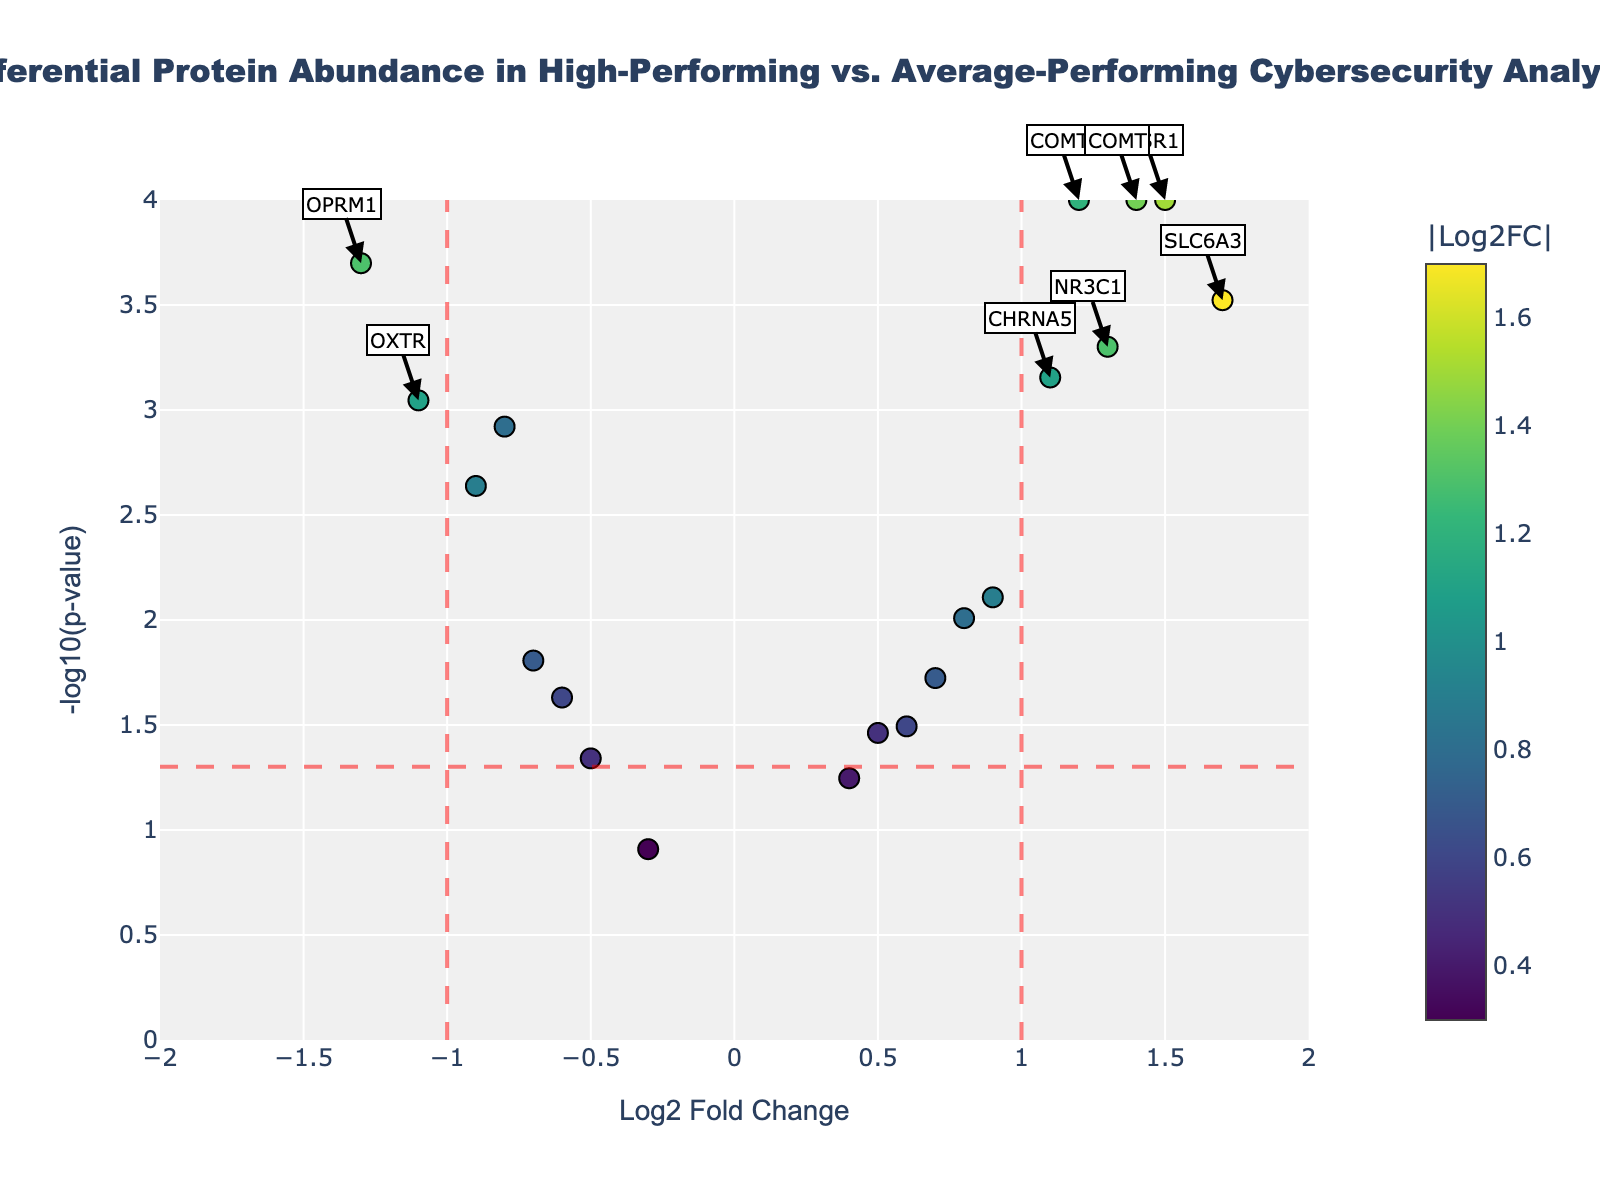What is the title of the figure? The title of the figure can be easily found at the top of the chart. It generally describes what the plot is representing.
Answer: Differential Protein Abundance in High-Performing vs. Average-Performing Cybersecurity Analysts How many proteins have a Log2FC greater than 1? Look at the x-axis and count the number of data points (proteins) located to the right of the vertical line at Log2FC = 1.
Answer: 5 Which protein has the highest -log10(p-value)? Identify the data point that is placed highest on the y-axis, which represents the highest -log10(p-value).
Answer: NPSR1 Is BNDF more significantly abundant in high-performing analysts or average-performing analysts? Check the position of BNDF on the x-axis. A negative Log2FC indicates lower abundance in high-performing analysts relative to average-performing analysts.
Answer: Average-performing analysts How many proteins are considered significant based on the thresholds (Log2FC > 1 or Log2FC < -1 and P-value < 0.05)? Count the number of data points that are beyond ±1 on the x-axis and above the threshold line on the y-axis (-log10(p-value) > 1.301).
Answer: 7 Which protein is located at (Log2FC = -1.1, -log10(p-value) = 3.0458)? Locate the data point at x = -1.1 and y = 3.0458 by finding the corresponding protein in the hover text.
Answer: OXTR Between COMT and DRD4, which protein has a higher -log10(p-value)? Compare the y-axis values of the data points for COMT and DRD4 to see which is higher.
Answer: COMT How does the abundance of OPRM1 in high-performers compare to average-performers? Check the Log2FC value of OPRM1. A negative value indicates lower abundance in high-performers.
Answer: Lower in high-performers List the proteins that are significantly more abundant in high-performers than in average-performers. Identify proteins with Log2FC > 1 and -log10(p-value) > 1.301 (right and above both threshold lines).
Answer: COMT, SLC6A3, NR3C1, NPSR1, CHRNA5 Compare the abundance significance between BNDF and SLC6A4. Check the positions of BNDF and SLC6A4 on the plot. Both proteins have negative Log2FC, but compare their -log10(p-value) values.
Answer: SLC6A4 is more significant 